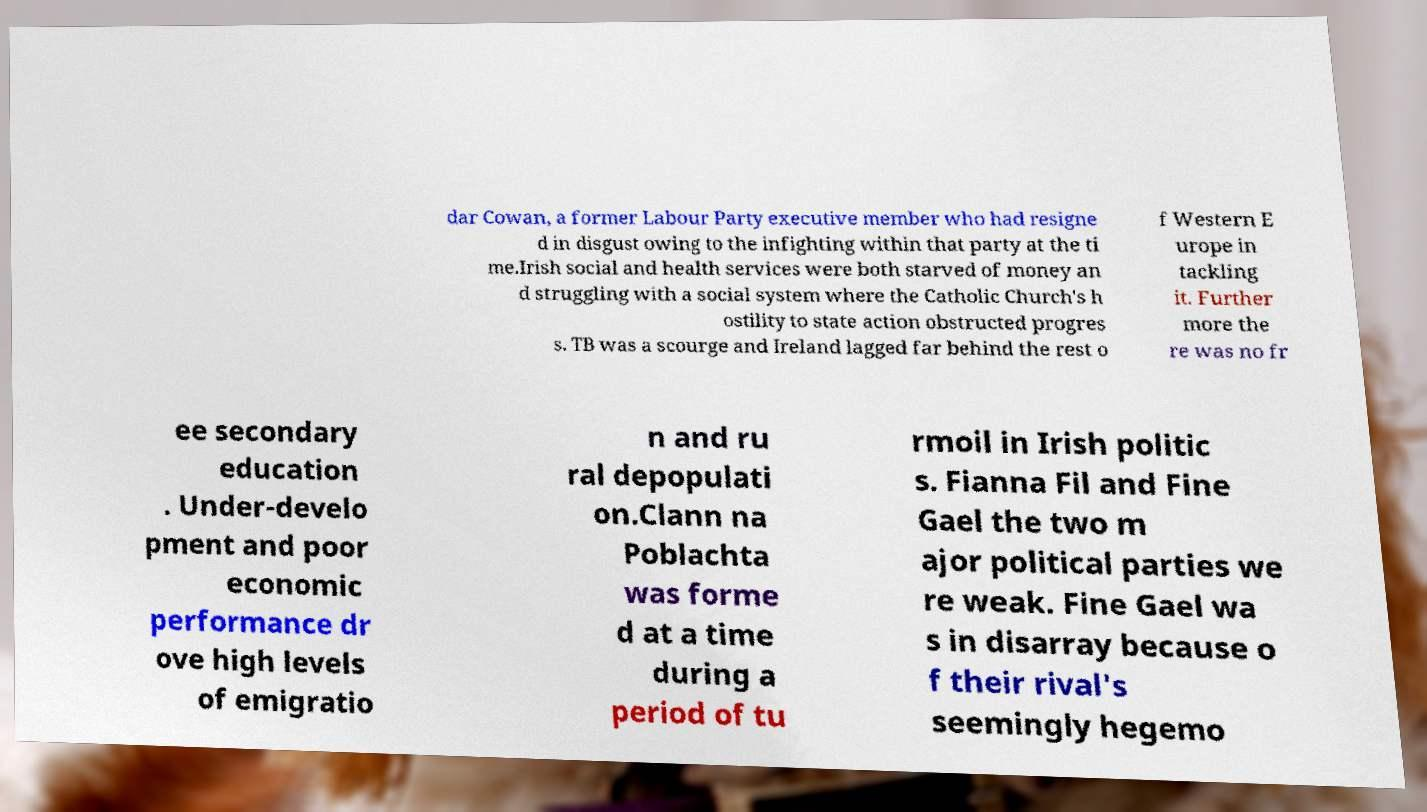Please read and relay the text visible in this image. What does it say? dar Cowan, a former Labour Party executive member who had resigne d in disgust owing to the infighting within that party at the ti me.Irish social and health services were both starved of money an d struggling with a social system where the Catholic Church's h ostility to state action obstructed progres s. TB was a scourge and Ireland lagged far behind the rest o f Western E urope in tackling it. Further more the re was no fr ee secondary education . Under-develo pment and poor economic performance dr ove high levels of emigratio n and ru ral depopulati on.Clann na Poblachta was forme d at a time during a period of tu rmoil in Irish politic s. Fianna Fil and Fine Gael the two m ajor political parties we re weak. Fine Gael wa s in disarray because o f their rival's seemingly hegemo 